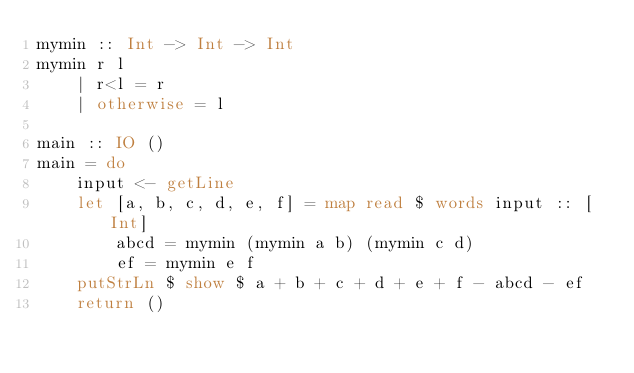<code> <loc_0><loc_0><loc_500><loc_500><_Haskell_>mymin :: Int -> Int -> Int
mymin r l
    | r<l = r
    | otherwise = l

main :: IO ()
main = do
    input <- getLine
    let [a, b, c, d, e, f] = map read $ words input :: [Int]
        abcd = mymin (mymin a b) (mymin c d)
        ef = mymin e f
    putStrLn $ show $ a + b + c + d + e + f - abcd - ef
    return ()
</code> 